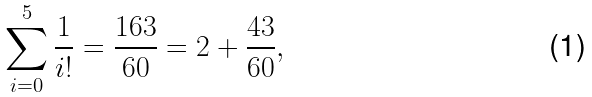<formula> <loc_0><loc_0><loc_500><loc_500>\sum _ { i = 0 } ^ { 5 } { \frac { 1 } { i ! } } = { \frac { 1 6 3 } { 6 0 } } = 2 + { \frac { 4 3 } { 6 0 } } ,</formula> 